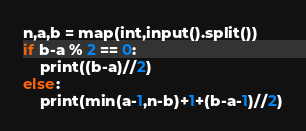Convert code to text. <code><loc_0><loc_0><loc_500><loc_500><_Python_>n,a,b = map(int,input().split())
if b-a % 2 == 0:
    print((b-a)//2)
else:
    print(min(a-1,n-b)+1+(b-a-1)//2)</code> 